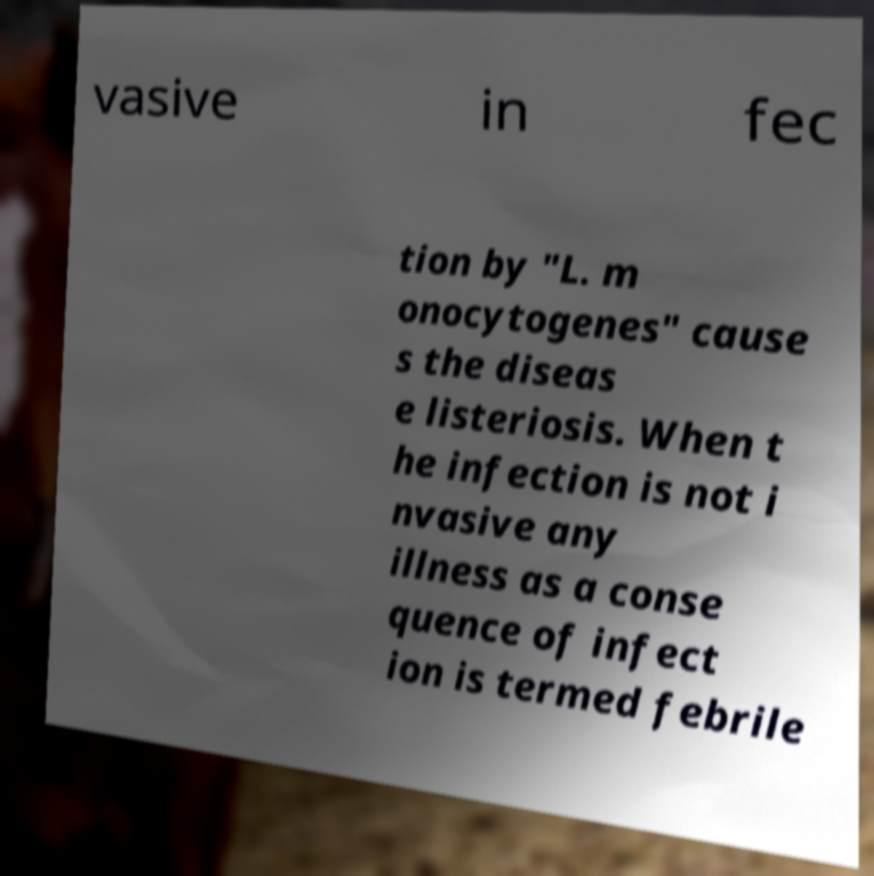Please identify and transcribe the text found in this image. vasive in fec tion by "L. m onocytogenes" cause s the diseas e listeriosis. When t he infection is not i nvasive any illness as a conse quence of infect ion is termed febrile 